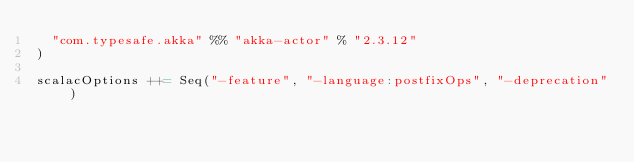Convert code to text. <code><loc_0><loc_0><loc_500><loc_500><_Scala_>  "com.typesafe.akka" %% "akka-actor" % "2.3.12"
)

scalacOptions ++= Seq("-feature", "-language:postfixOps", "-deprecation")

</code> 